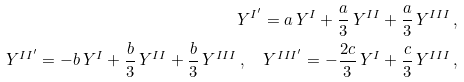Convert formula to latex. <formula><loc_0><loc_0><loc_500><loc_500>Y ^ { I ^ { \prime } } = a \, Y ^ { I } + \frac { a } { 3 } \, Y ^ { I I } + \frac { a } { 3 } \, Y ^ { I I I } \, , \\ Y ^ { I I ^ { \prime } } = - b \, Y ^ { I } + \frac { b } { 3 } \, Y ^ { I I } + \frac { b } { 3 } \, Y ^ { I I I } \, , \quad Y ^ { I I I ^ { \prime } } = - \frac { 2 c } { 3 } \, Y ^ { I } + \frac { c } { 3 } \, Y ^ { I I I } \, ,</formula> 